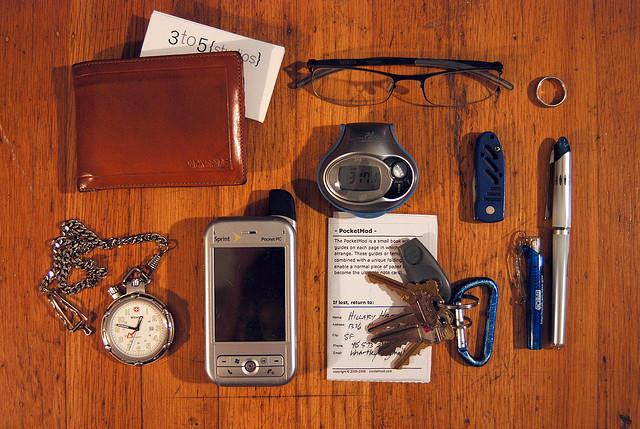What kind of phone is shown?
Give a very brief answer. Cell phone. What item is to the right of the watch?
Keep it brief. Phone. What items are on the table?
Write a very short answer. Wallet, cell phone, keys, glasses, pen, pocket knife, ring, watch, note, business card, clock. 